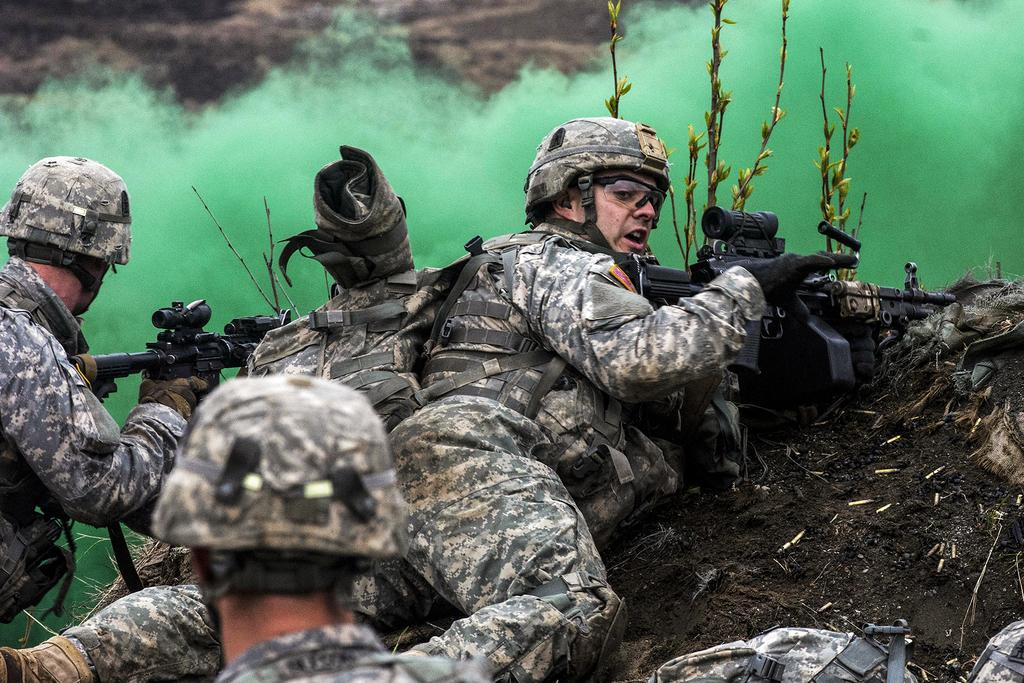How many persons can be seen in the image? There are persons in the image. What are two of the persons holding? Two persons are holding guns. What is on the ground in the image? There is a bag on the ground. What can be seen in the background of the image? There are plants and green color smoke visible in the background of the image. What type of baseball can be seen in the image? There is no baseball present in the image. Is there a bell ringing in the background of the image? There is no bell present in the image. 